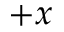<formula> <loc_0><loc_0><loc_500><loc_500>+ x</formula> 